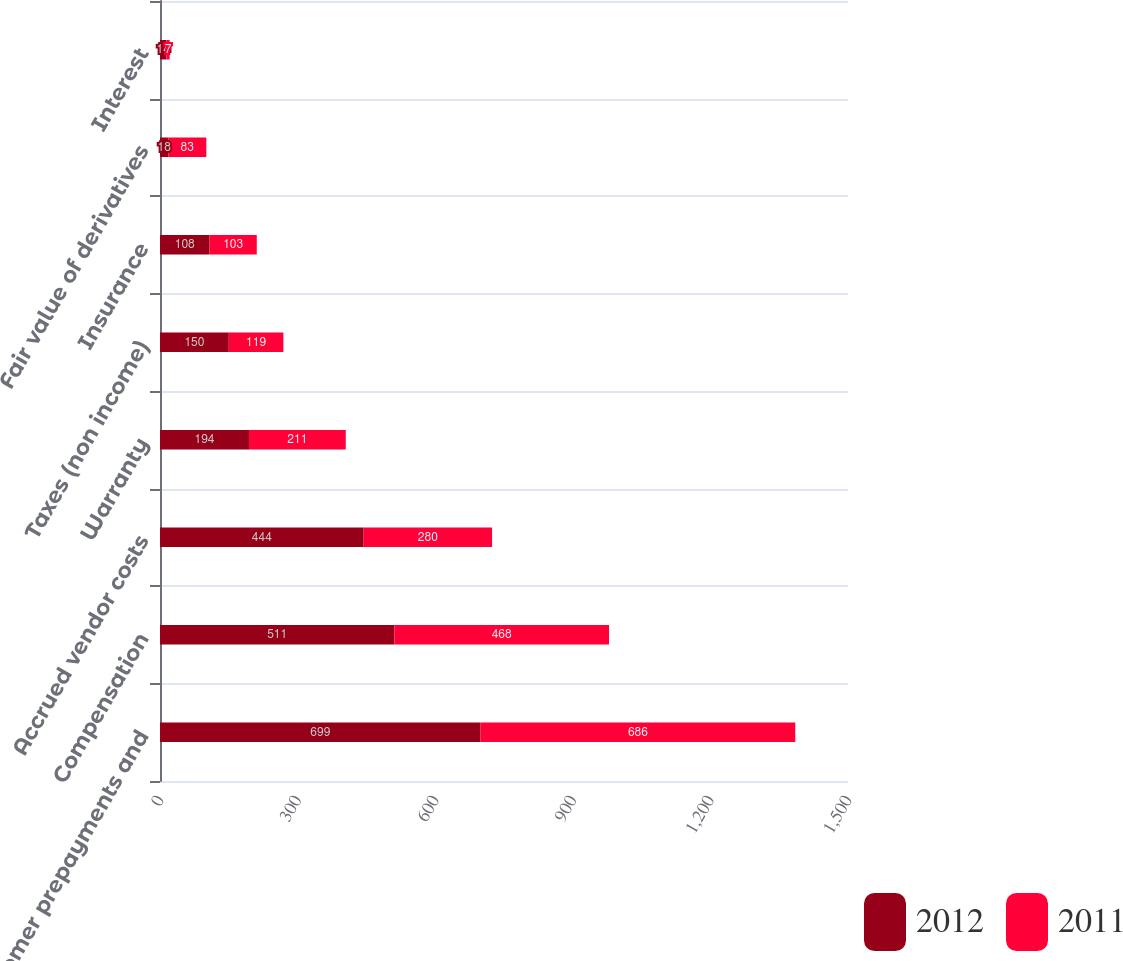Convert chart. <chart><loc_0><loc_0><loc_500><loc_500><stacked_bar_chart><ecel><fcel>Customer prepayments and<fcel>Compensation<fcel>Accrued vendor costs<fcel>Warranty<fcel>Taxes (non income)<fcel>Insurance<fcel>Fair value of derivatives<fcel>Interest<nl><fcel>2012<fcel>699<fcel>511<fcel>444<fcel>194<fcel>150<fcel>108<fcel>18<fcel>14<nl><fcel>2011<fcel>686<fcel>468<fcel>280<fcel>211<fcel>119<fcel>103<fcel>83<fcel>7<nl></chart> 